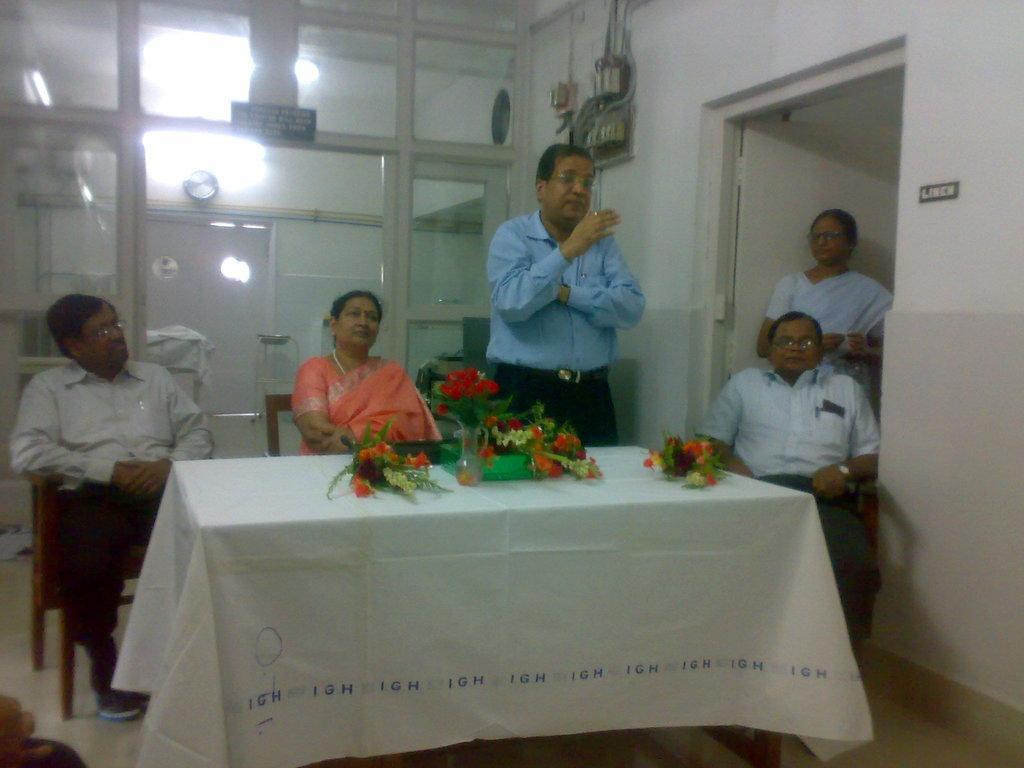In one or two sentences, can you explain what this image depicts? Here we can see three persons are sitting on the chairs. This is table. On the table there is a cloth and flower bouquets. This is floor. Here we can see two persons are standing on the floor. There is a wall and this is door. Here we can see lights and this is glass. 